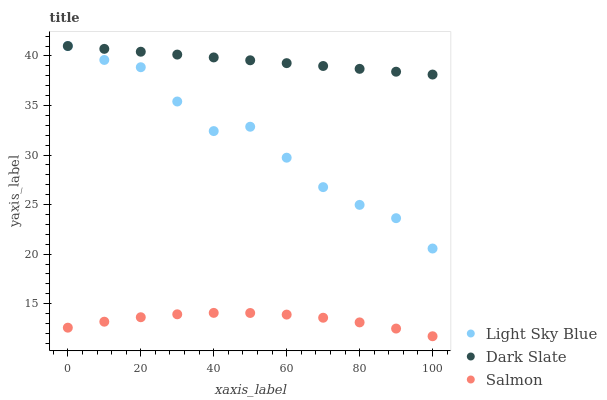Does Salmon have the minimum area under the curve?
Answer yes or no. Yes. Does Dark Slate have the maximum area under the curve?
Answer yes or no. Yes. Does Light Sky Blue have the minimum area under the curve?
Answer yes or no. No. Does Light Sky Blue have the maximum area under the curve?
Answer yes or no. No. Is Dark Slate the smoothest?
Answer yes or no. Yes. Is Light Sky Blue the roughest?
Answer yes or no. Yes. Is Salmon the smoothest?
Answer yes or no. No. Is Salmon the roughest?
Answer yes or no. No. Does Salmon have the lowest value?
Answer yes or no. Yes. Does Light Sky Blue have the lowest value?
Answer yes or no. No. Does Light Sky Blue have the highest value?
Answer yes or no. Yes. Does Salmon have the highest value?
Answer yes or no. No. Is Salmon less than Light Sky Blue?
Answer yes or no. Yes. Is Dark Slate greater than Salmon?
Answer yes or no. Yes. Does Dark Slate intersect Light Sky Blue?
Answer yes or no. Yes. Is Dark Slate less than Light Sky Blue?
Answer yes or no. No. Is Dark Slate greater than Light Sky Blue?
Answer yes or no. No. Does Salmon intersect Light Sky Blue?
Answer yes or no. No. 